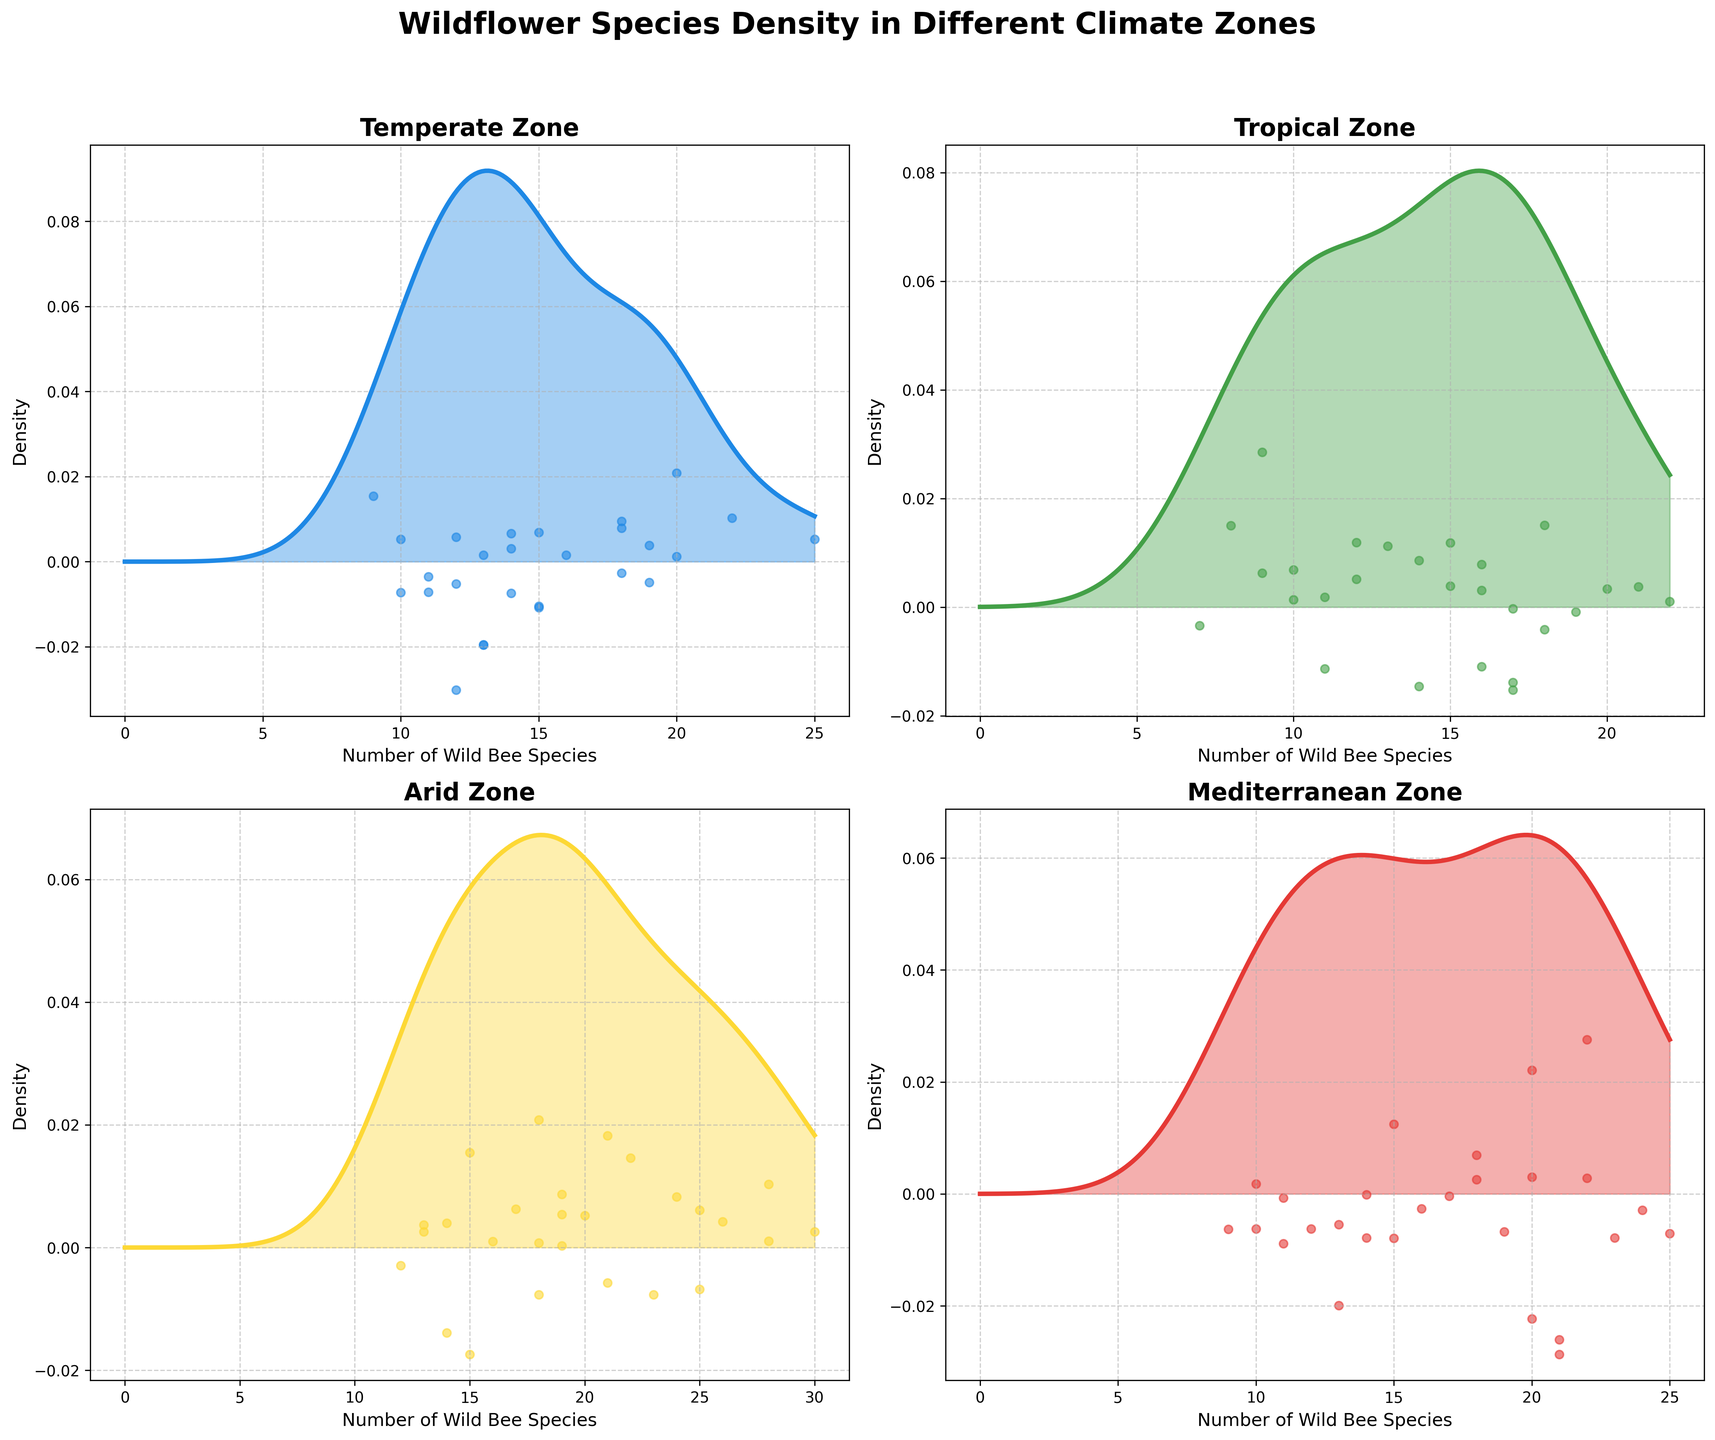What is the highest density observed in the Temperate Zone? To find the highest density, look at the peak of the density curve for the Temperate Zone subplot. This would be the y-value at the highest point on the plot.
Answer: The specific y-value is not numerically provided in the plot Which climate zone has the widest spread in the number of wild bee species? To determine this, observe the x-axis range for each climate zone's density plot. The climate zone with the widest spread will have the broadest range of x-values where the density is significant.
Answer: Arid Compare the peak densities of the Tropical and Mediterranean Zones. Which one is higher? Look at the peak of the density curves for both zones and compare their y-values. The higher peak will have a greater density value.
Answer: Mediterranean Zone What is the general trend in density for the number of wild bee species in the Arid Zone? Look at the density curve for the Arid Zone and describe its overall shape.
Answer: The density curve is relatively high and spread out In which climate zone does the density of wild bee species decrease the fastest after the peak? To find this, look at the density curves and assess which curve drops most steeply after reaching its peak density.
Answer: Temperate Zone How do the number of wild bee species in the Mediterranean Zone compare to those in the Tropical Zone in terms of highest density? Compare the peak points of the density curves for both zones to see which has a higher peak, indicating a higher density of wild bee species.
Answer: Mediterranean Zone What is the range of wild bee species in the Temperate Zone with significant density? Identify the starting and ending x-values where the density curve (Temperate Zone) is significant or above a certain low threshold level. Summarize these x-values as range.
Answer: Approximately 10 to 25 How does the density of wild bee species in the Temperate Zone compare to the Tropical Zone? Compare the shape, peak, and spread of the density curves for the Temperate and Tropical Zones to understand the differences.
Answer: Temperate zone has lower and sharper peak; Tropical is more spread out Which climate zone shows the least variation in the number of wild bee species? Find the density plot with the narrowest spread on the x-axis. Less variation will be indicated by a tighter clustering around the peak.
Answer: Mediterranean Zone 